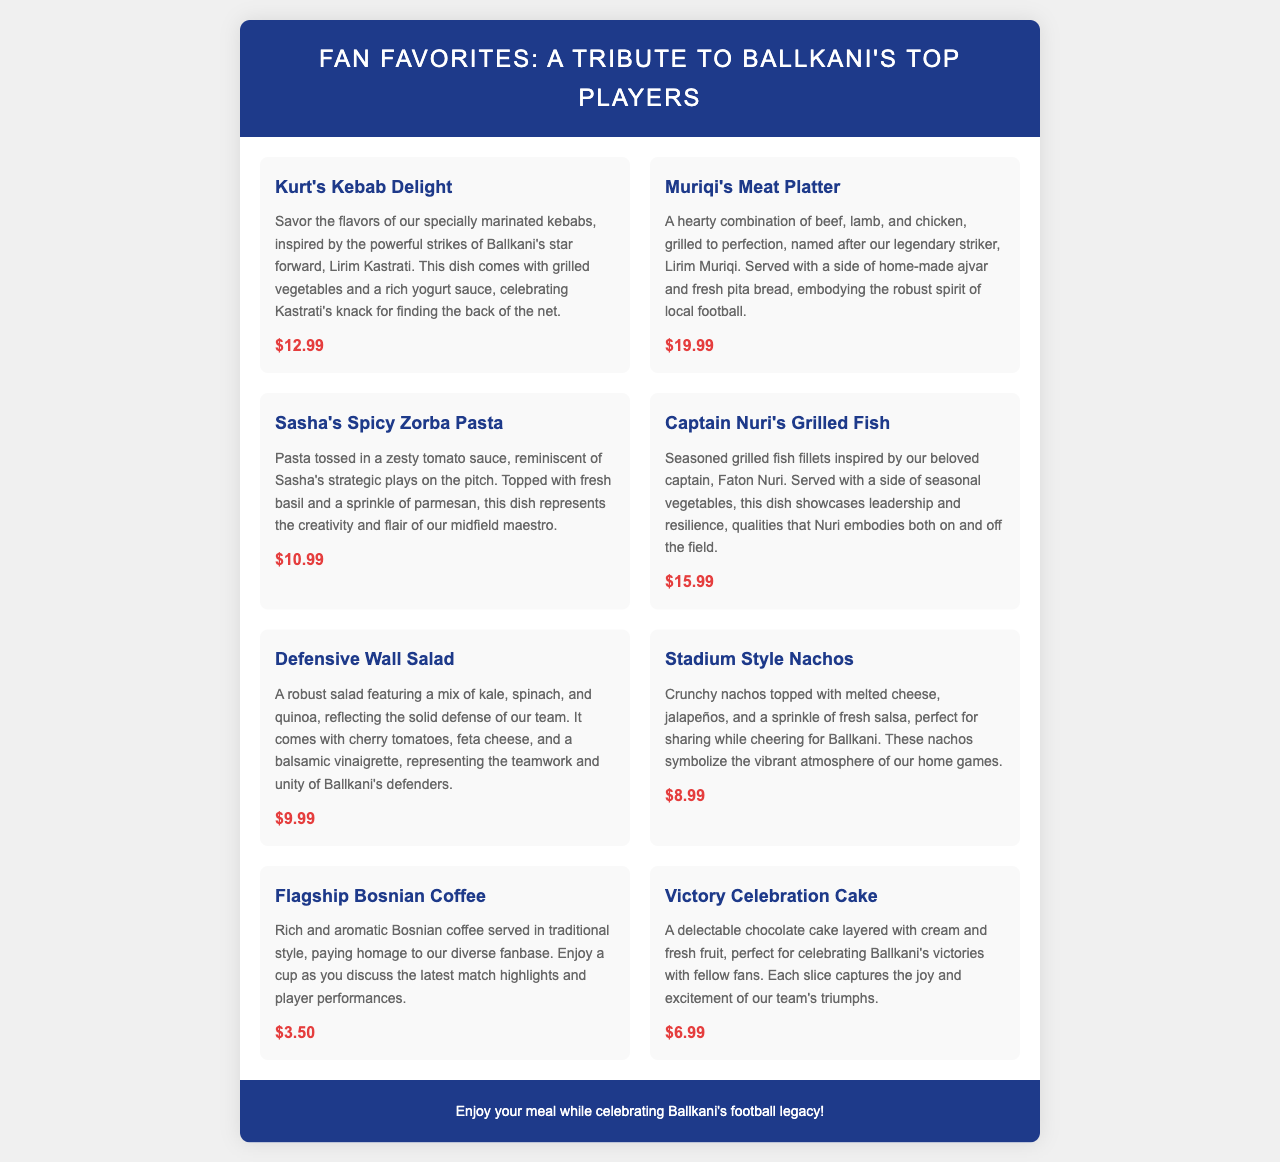What is the dish inspired by Lirim Kastrati? The dish inspired by Lirim Kastrati is named "Kurt's Kebab Delight."
Answer: Kurt's Kebab Delight How much does the "Victory Celebration Cake" cost? The price of the "Victory Celebration Cake" is listed in the menu.
Answer: $6.99 What type of coffee is offered in the menu? The menu mentions a specific type of coffee, which is a local beverage.
Answer: Bosnian coffee Which dish represents Ballkani's defenders? The dish that represents Ballkani's defenders is described with a specific name reflecting their qualities.
Answer: Defensive Wall Salad What is served with "Captain Nuri's Grilled Fish"? The side dish that accompanies "Captain Nuri's Grilled Fish" is mentioned in the description.
Answer: Seasonal vegetables What ingredient is included in Sasha's dish? The specific ingredient that is part of Sasha's dish is detailed in its description.
Answer: Fresh basil How many types of meat are in Muriqi's Meat Platter? The number of different types of meat in Muriqi's Meat Platter is stated clearly.
Answer: Three Which dish symbolizes the vibrant atmosphere of home games? The dish that symbolizes the vibrant atmosphere of home games is indicated in the menu.
Answer: Stadium Style Nachos 